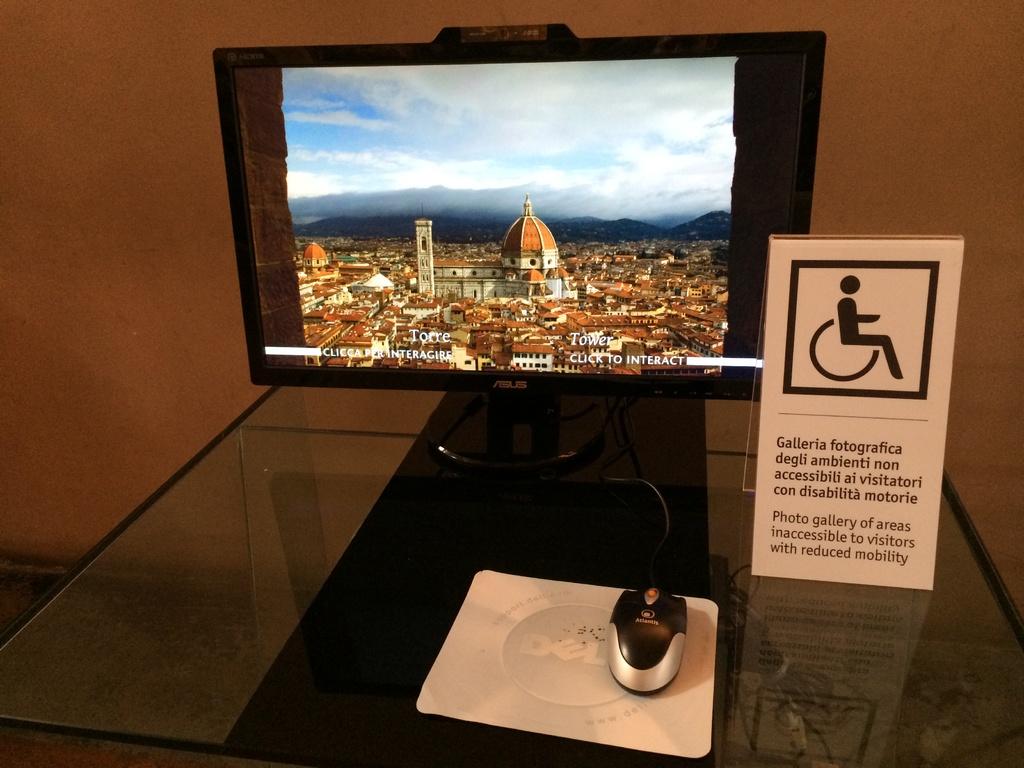What brand is the monitor?
Offer a terse response. Asus. 